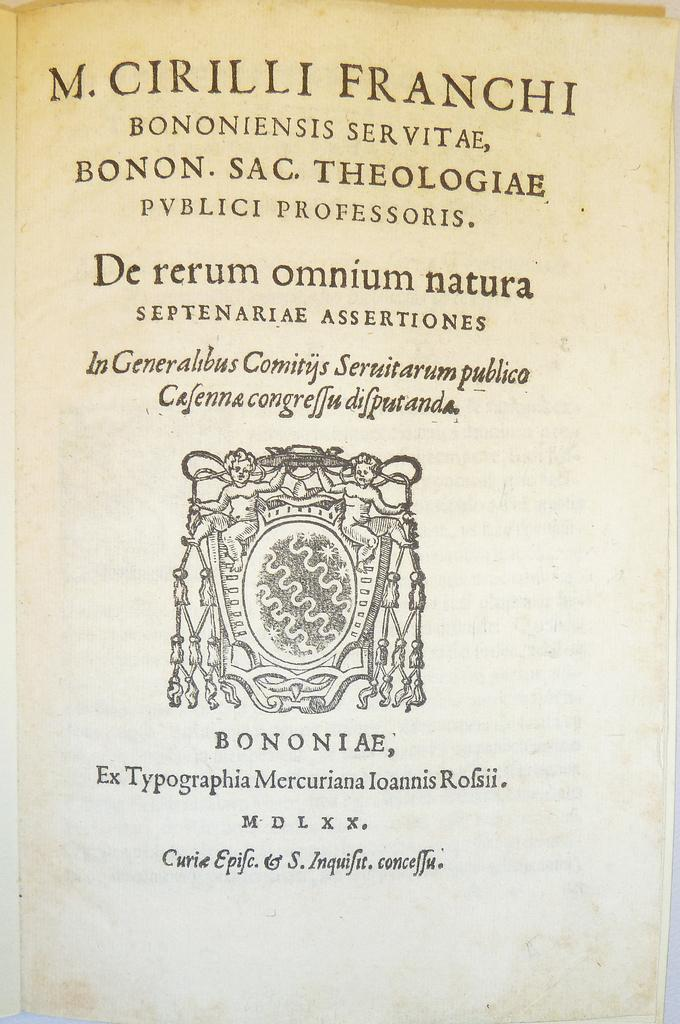Provide a one-sentence caption for the provided image. A very old book has a publication date of M D L X X on its title page. 